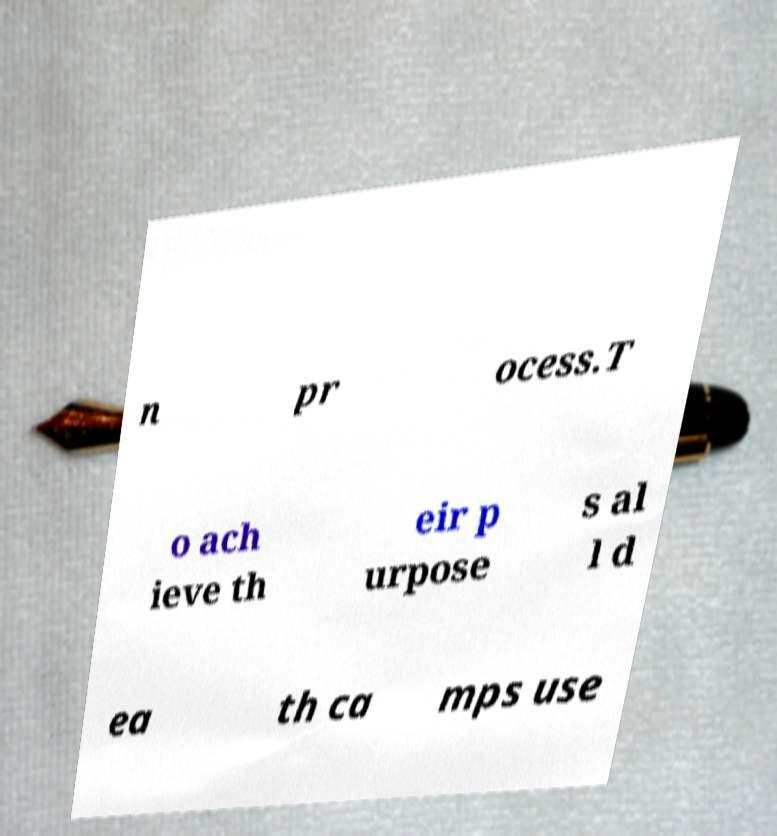Could you assist in decoding the text presented in this image and type it out clearly? n pr ocess.T o ach ieve th eir p urpose s al l d ea th ca mps use 